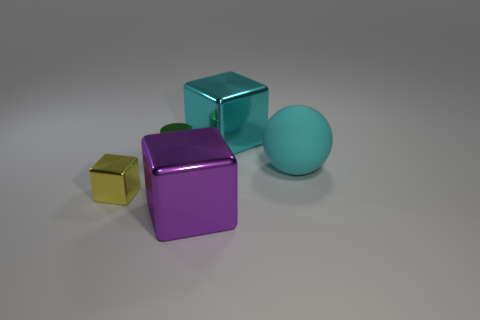Subtract all balls. How many objects are left? 4 Subtract 1 cylinders. How many cylinders are left? 0 Subtract all green balls. Subtract all gray cylinders. How many balls are left? 1 Subtract all gray balls. How many yellow cubes are left? 1 Subtract all large matte cubes. Subtract all cyan cubes. How many objects are left? 4 Add 4 yellow metal cubes. How many yellow metal cubes are left? 5 Add 1 red rubber balls. How many red rubber balls exist? 1 Add 4 big things. How many objects exist? 9 Subtract all big cubes. How many cubes are left? 1 Subtract 0 brown cylinders. How many objects are left? 5 